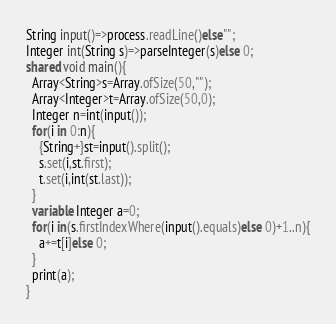<code> <loc_0><loc_0><loc_500><loc_500><_Ceylon_>String input()=>process.readLine()else""; 
Integer int(String s)=>parseInteger(s)else 0;
shared void main(){
  Array<String>s=Array.ofSize(50,"");
  Array<Integer>t=Array.ofSize(50,0);
  Integer n=int(input());
  for(i in 0:n){
    {String+}st=input().split();
    s.set(i,st.first);
    t.set(i,int(st.last));
  }
  variable Integer a=0;
  for(i in(s.firstIndexWhere(input().equals)else 0)+1..n){
    a+=t[i]else 0;
  }
  print(a);
}
</code> 